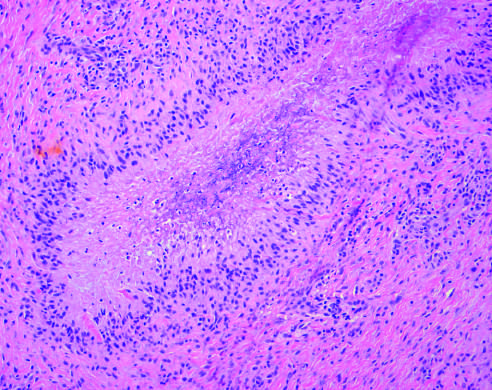what is rimmed by palisaded histiocytes?
Answer the question using a single word or phrase. Central necrosis 